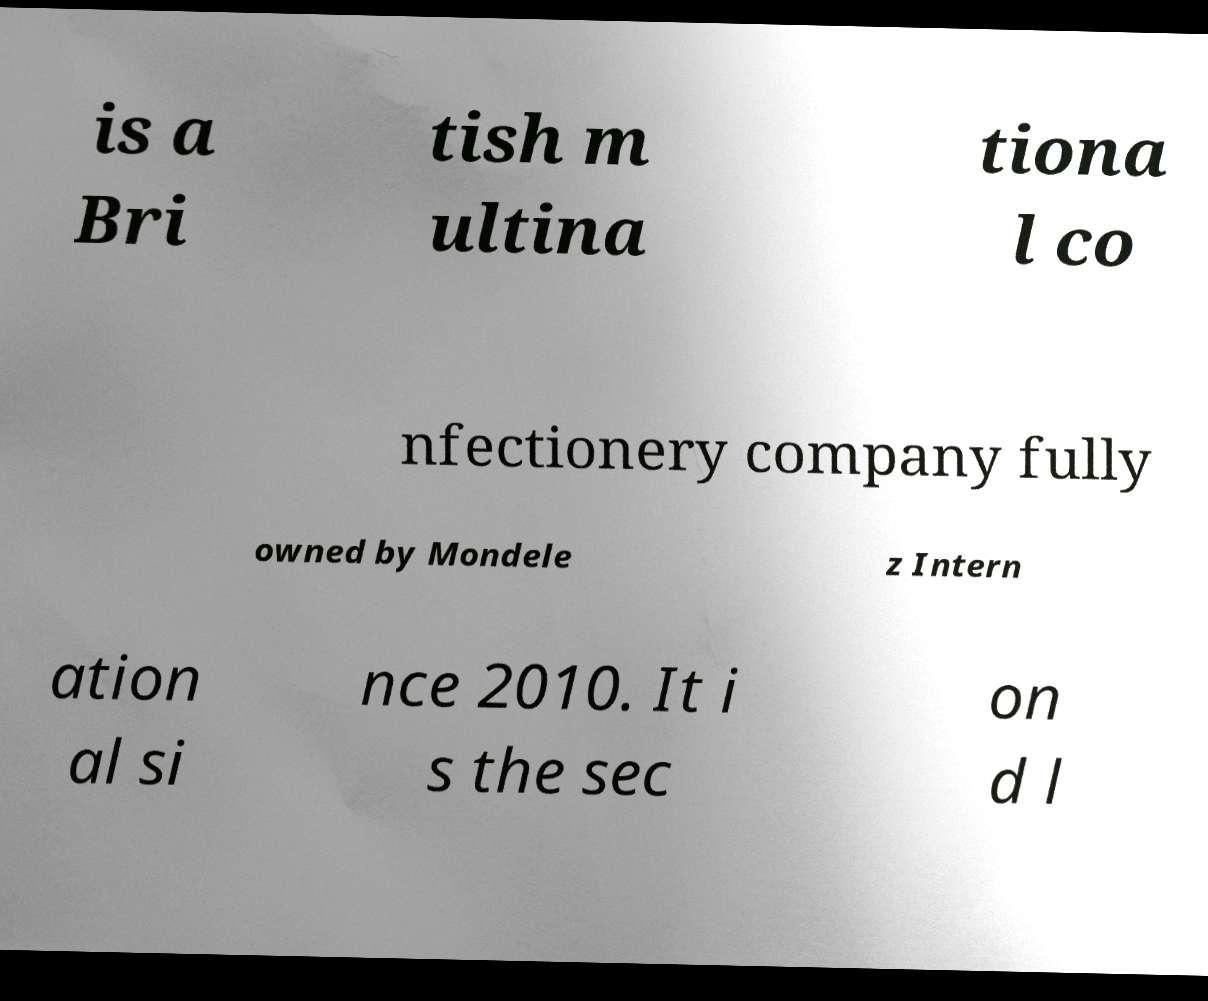What messages or text are displayed in this image? I need them in a readable, typed format. is a Bri tish m ultina tiona l co nfectionery company fully owned by Mondele z Intern ation al si nce 2010. It i s the sec on d l 